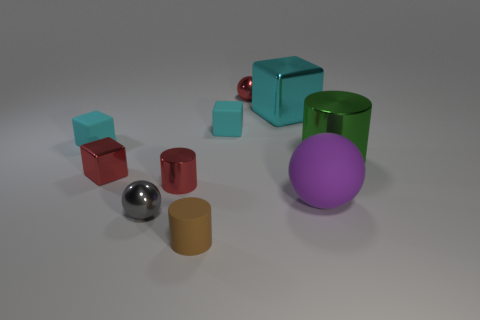What is the shape of the big green object that is the same material as the gray thing?
Provide a short and direct response. Cylinder. There is a tiny brown thing; what shape is it?
Give a very brief answer. Cylinder. What color is the thing that is right of the big cyan object and in front of the large metal cylinder?
Provide a short and direct response. Purple. There is a gray object that is the same size as the brown rubber thing; what shape is it?
Give a very brief answer. Sphere. Is there another gray object of the same shape as the gray metal thing?
Make the answer very short. No. Does the purple thing have the same material as the cyan block that is left of the tiny gray sphere?
Provide a succinct answer. Yes. What color is the metal ball that is to the right of the cylinder in front of the big purple ball to the right of the red block?
Give a very brief answer. Red. There is a block that is the same size as the green cylinder; what is it made of?
Ensure brevity in your answer.  Metal. How many big blocks are the same material as the small red cylinder?
Your response must be concise. 1. There is a sphere that is to the right of the cyan shiny cube; is its size the same as the metallic sphere behind the large green cylinder?
Give a very brief answer. No. 